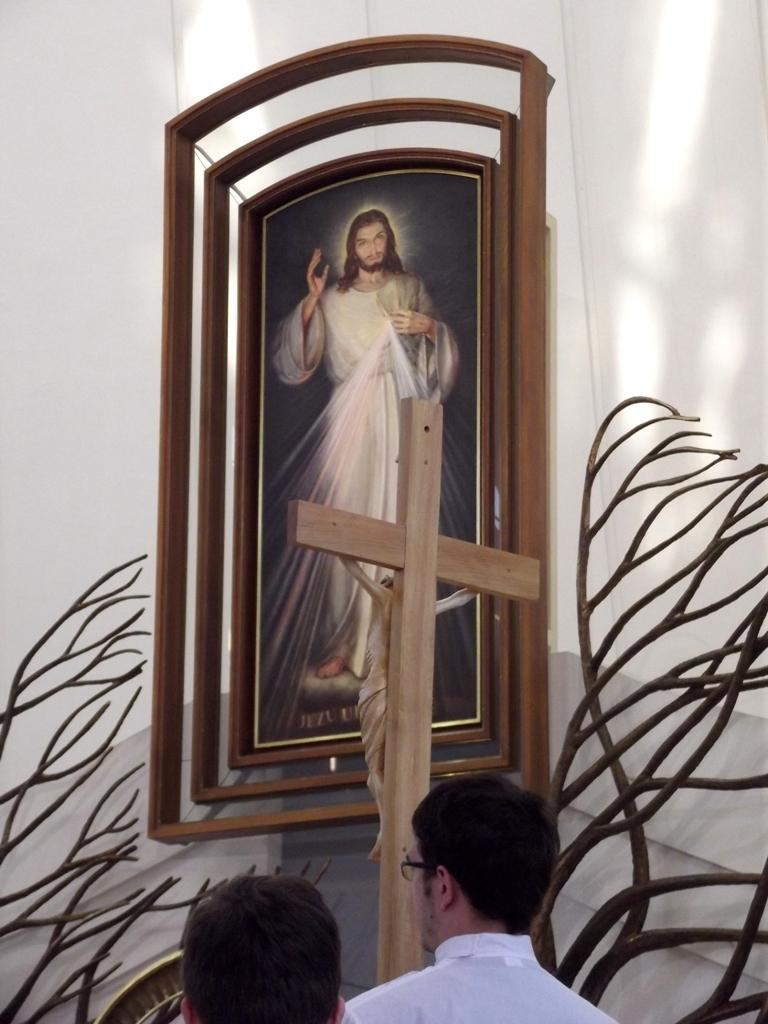How many people are in the image? There are two persons in the image. What can be seen on the cross in the image? There is a statue on the cross. What type of vegetation is visible in the image? There are branches visible in the image. What is present on the wall in the image? There is a photo frame on the wall in the image. How many babies are being held by the persons in the image? There are no babies present in the image; it only features two persons and a cross with a statue. 